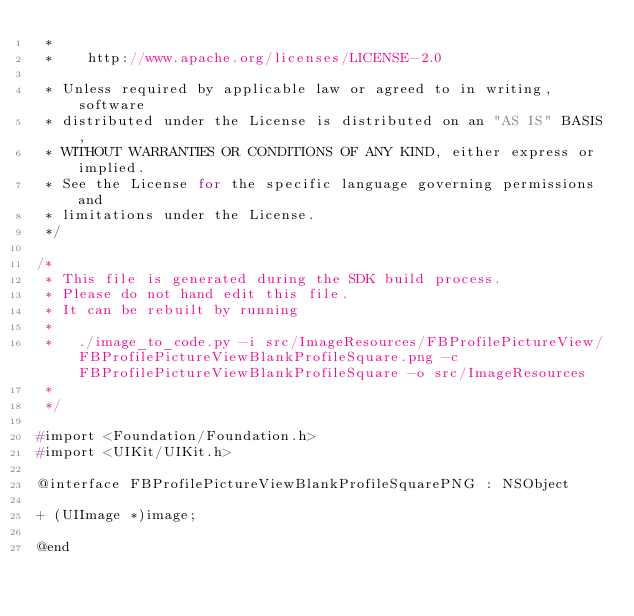Convert code to text. <code><loc_0><loc_0><loc_500><loc_500><_C_> *
 *    http://www.apache.org/licenses/LICENSE-2.0
 
 * Unless required by applicable law or agreed to in writing, software
 * distributed under the License is distributed on an "AS IS" BASIS,
 * WITHOUT WARRANTIES OR CONDITIONS OF ANY KIND, either express or implied.
 * See the License for the specific language governing permissions and
 * limitations under the License.
 */

/*
 * This file is generated during the SDK build process.
 * Please do not hand edit this file.
 * It can be rebuilt by running 
 *
 *   ./image_to_code.py -i src/ImageResources/FBProfilePictureView/FBProfilePictureViewBlankProfileSquare.png -c FBProfilePictureViewBlankProfileSquare -o src/ImageResources
 *
 */

#import <Foundation/Foundation.h>
#import <UIKit/UIKit.h>

@interface FBProfilePictureViewBlankProfileSquarePNG : NSObject

+ (UIImage *)image;

@end</code> 